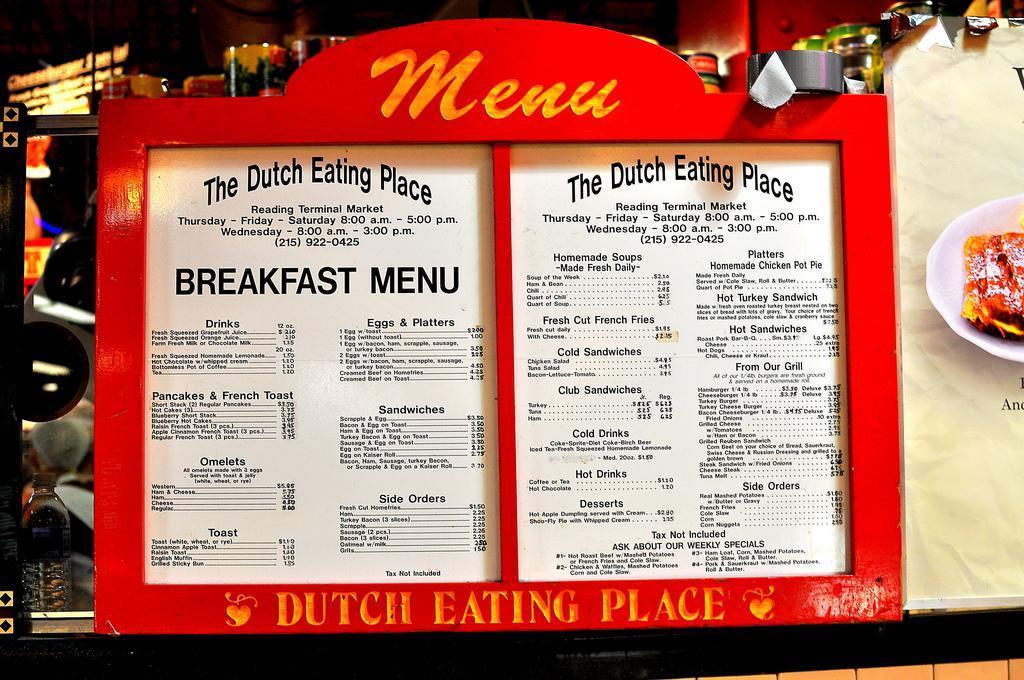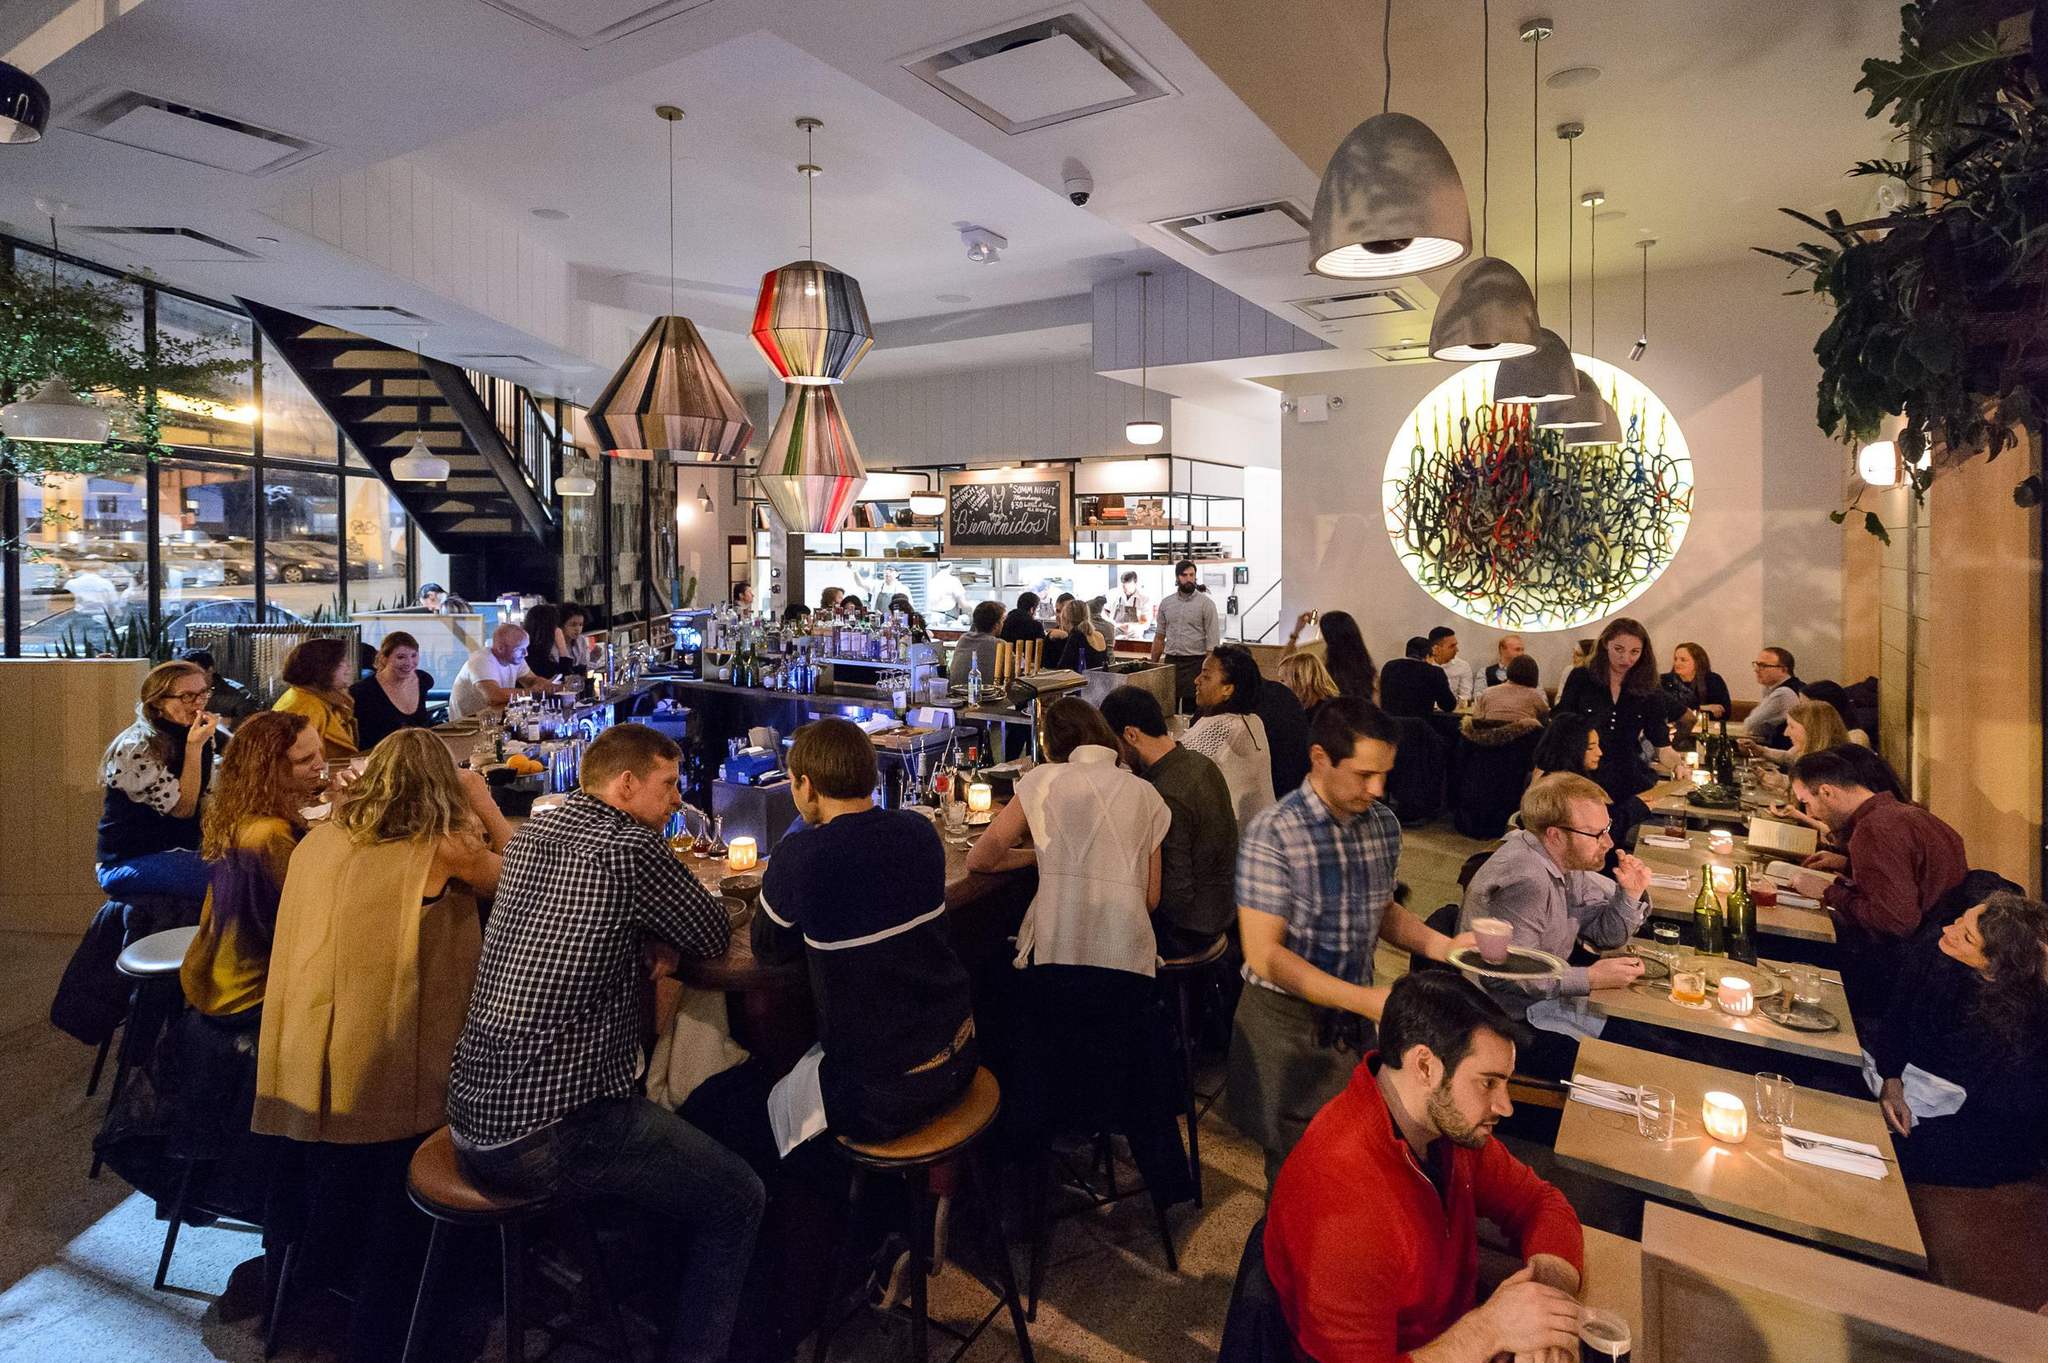The first image is the image on the left, the second image is the image on the right. Considering the images on both sides, is "In at least one image the is a menu framed in red sitting on a black countertop." valid? Answer yes or no. Yes. The first image is the image on the left, the second image is the image on the right. Analyze the images presented: Is the assertion "More than six people are sitting on bar stools." valid? Answer yes or no. Yes. 